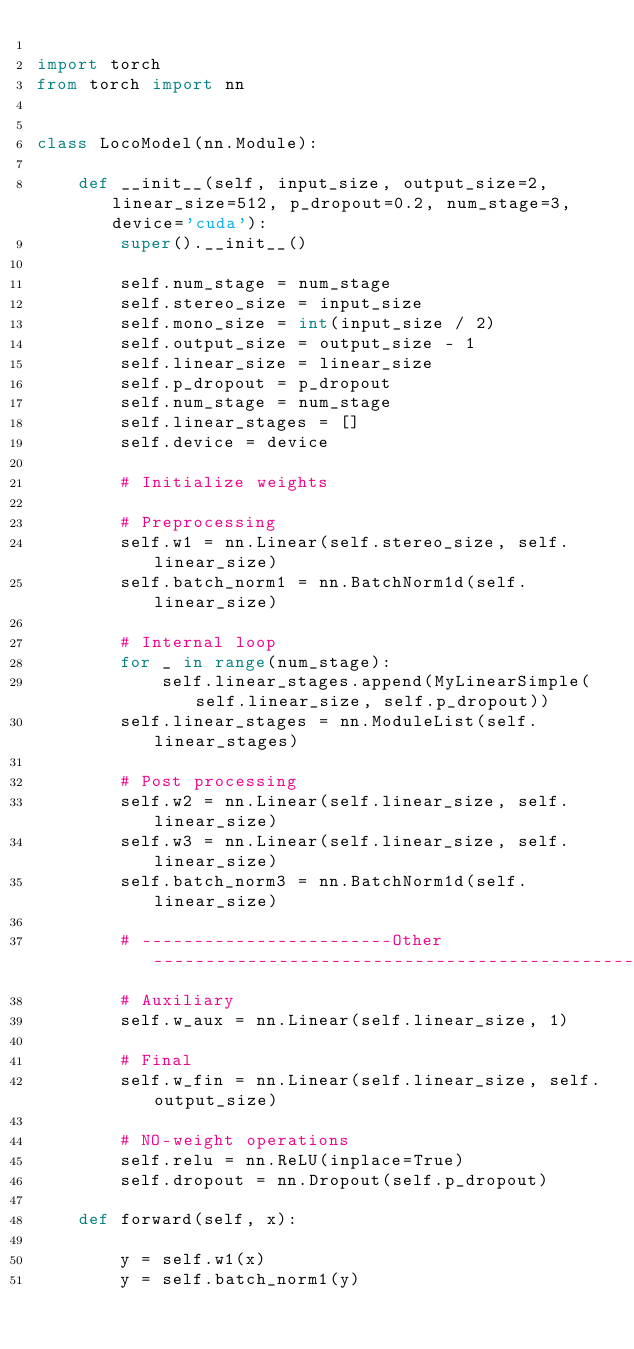Convert code to text. <code><loc_0><loc_0><loc_500><loc_500><_Python_>
import torch
from torch import nn


class LocoModel(nn.Module):

    def __init__(self, input_size, output_size=2, linear_size=512, p_dropout=0.2, num_stage=3, device='cuda'):
        super().__init__()

        self.num_stage = num_stage
        self.stereo_size = input_size
        self.mono_size = int(input_size / 2)
        self.output_size = output_size - 1
        self.linear_size = linear_size
        self.p_dropout = p_dropout
        self.num_stage = num_stage
        self.linear_stages = []
        self.device = device

        # Initialize weights

        # Preprocessing
        self.w1 = nn.Linear(self.stereo_size, self.linear_size)
        self.batch_norm1 = nn.BatchNorm1d(self.linear_size)

        # Internal loop
        for _ in range(num_stage):
            self.linear_stages.append(MyLinearSimple(self.linear_size, self.p_dropout))
        self.linear_stages = nn.ModuleList(self.linear_stages)

        # Post processing
        self.w2 = nn.Linear(self.linear_size, self.linear_size)
        self.w3 = nn.Linear(self.linear_size, self.linear_size)
        self.batch_norm3 = nn.BatchNorm1d(self.linear_size)

        # ------------------------Other----------------------------------------------
        # Auxiliary
        self.w_aux = nn.Linear(self.linear_size, 1)

        # Final
        self.w_fin = nn.Linear(self.linear_size, self.output_size)

        # NO-weight operations
        self.relu = nn.ReLU(inplace=True)
        self.dropout = nn.Dropout(self.p_dropout)

    def forward(self, x):

        y = self.w1(x)
        y = self.batch_norm1(y)</code> 